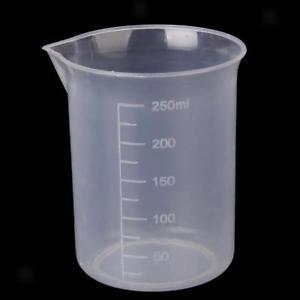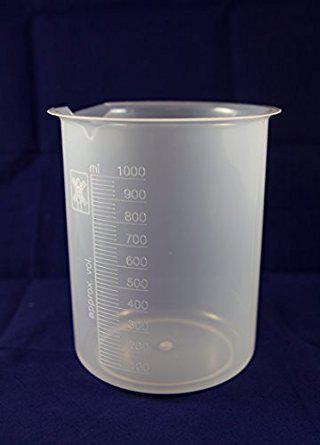The first image is the image on the left, the second image is the image on the right. Examine the images to the left and right. Is the description "The measuring cup in one of the pictures has black writing and markings on it." accurate? Answer yes or no. No. The first image is the image on the left, the second image is the image on the right. For the images displayed, is the sentence "The left and right image contains the same number of beakers with at least one with a handle." factually correct? Answer yes or no. No. 